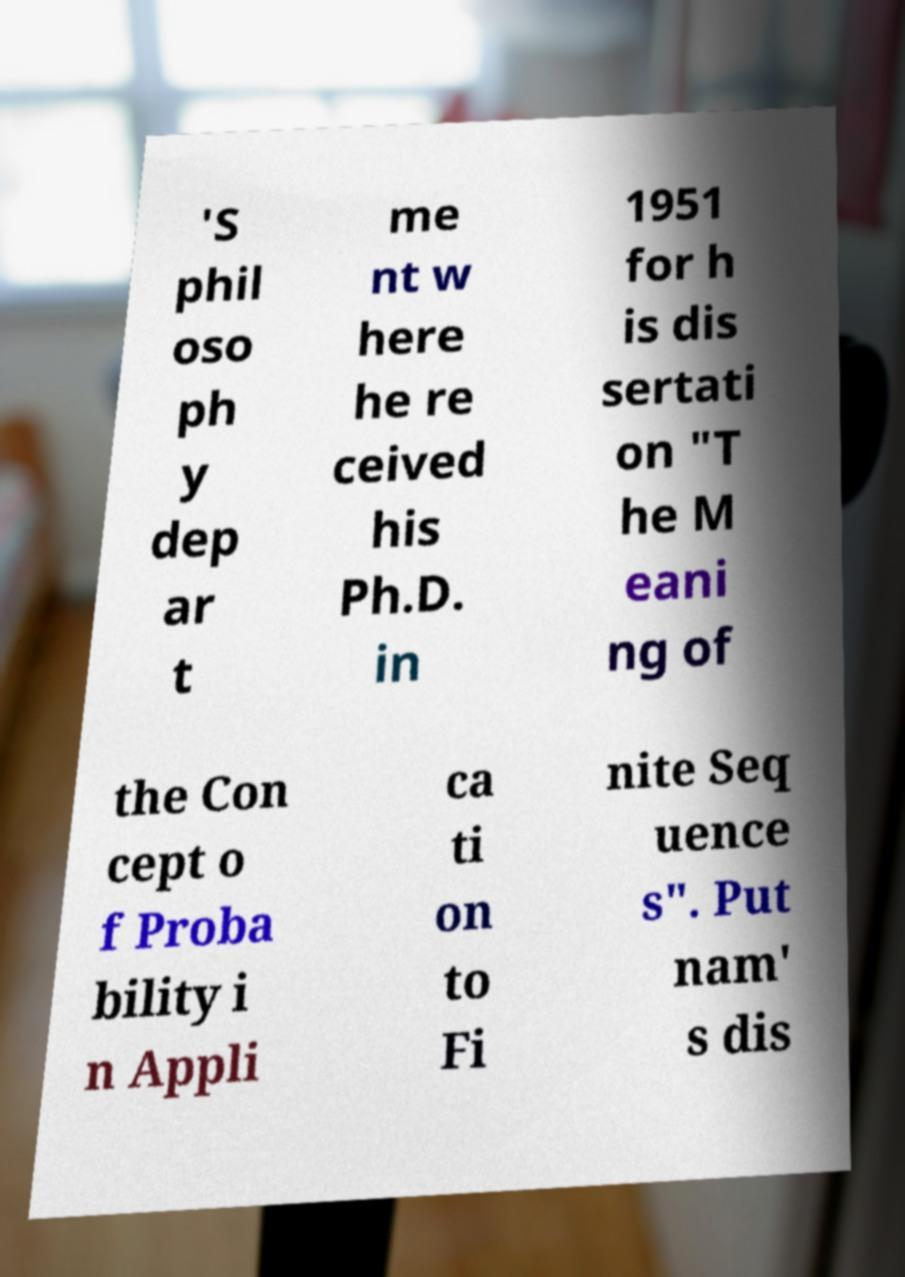Please identify and transcribe the text found in this image. 'S phil oso ph y dep ar t me nt w here he re ceived his Ph.D. in 1951 for h is dis sertati on "T he M eani ng of the Con cept o f Proba bility i n Appli ca ti on to Fi nite Seq uence s". Put nam' s dis 